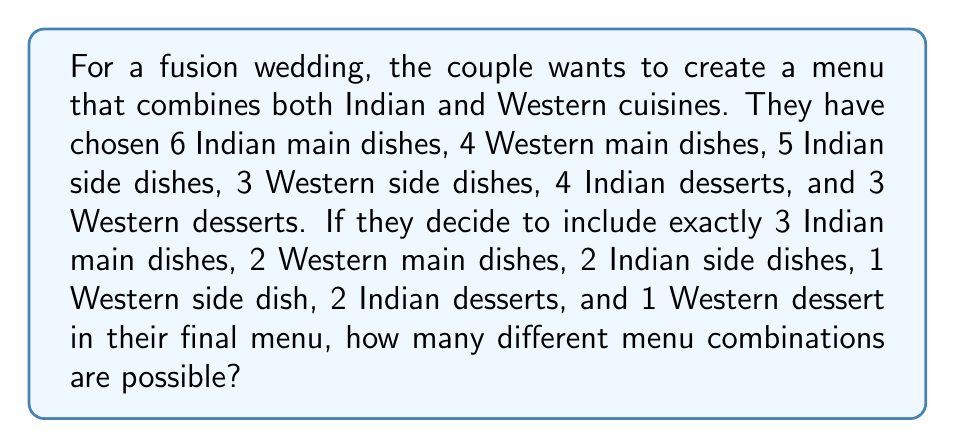Solve this math problem. To solve this problem, we need to use the multiplication principle of counting and combinations. Let's break it down step by step:

1. Indian main dishes: Choose 3 out of 6
   $${6 \choose 3} = \frac{6!}{3!(6-3)!} = \frac{6!}{3!3!} = 20$$

2. Western main dishes: Choose 2 out of 4
   $${4 \choose 2} = \frac{4!}{2!(4-2)!} = \frac{4!}{2!2!} = 6$$

3. Indian side dishes: Choose 2 out of 5
   $${5 \choose 2} = \frac{5!}{2!(5-2)!} = \frac{5!}{2!3!} = 10$$

4. Western side dishes: Choose 1 out of 3
   $${3 \choose 1} = \frac{3!}{1!(3-1)!} = \frac{3!}{1!2!} = 3$$

5. Indian desserts: Choose 2 out of 4
   $${4 \choose 2} = \frac{4!}{2!(4-2)!} = \frac{4!}{2!2!} = 6$$

6. Western desserts: Choose 1 out of 3
   $${3 \choose 1} = \frac{3!}{1!(3-1)!} = \frac{3!}{1!2!} = 3$$

Now, we apply the multiplication principle. The total number of possible menu combinations is the product of all these individual combinations:

$$20 \times 6 \times 10 \times 3 \times 6 \times 3 = 21,600$$
Answer: 21,600 different menu combinations are possible. 